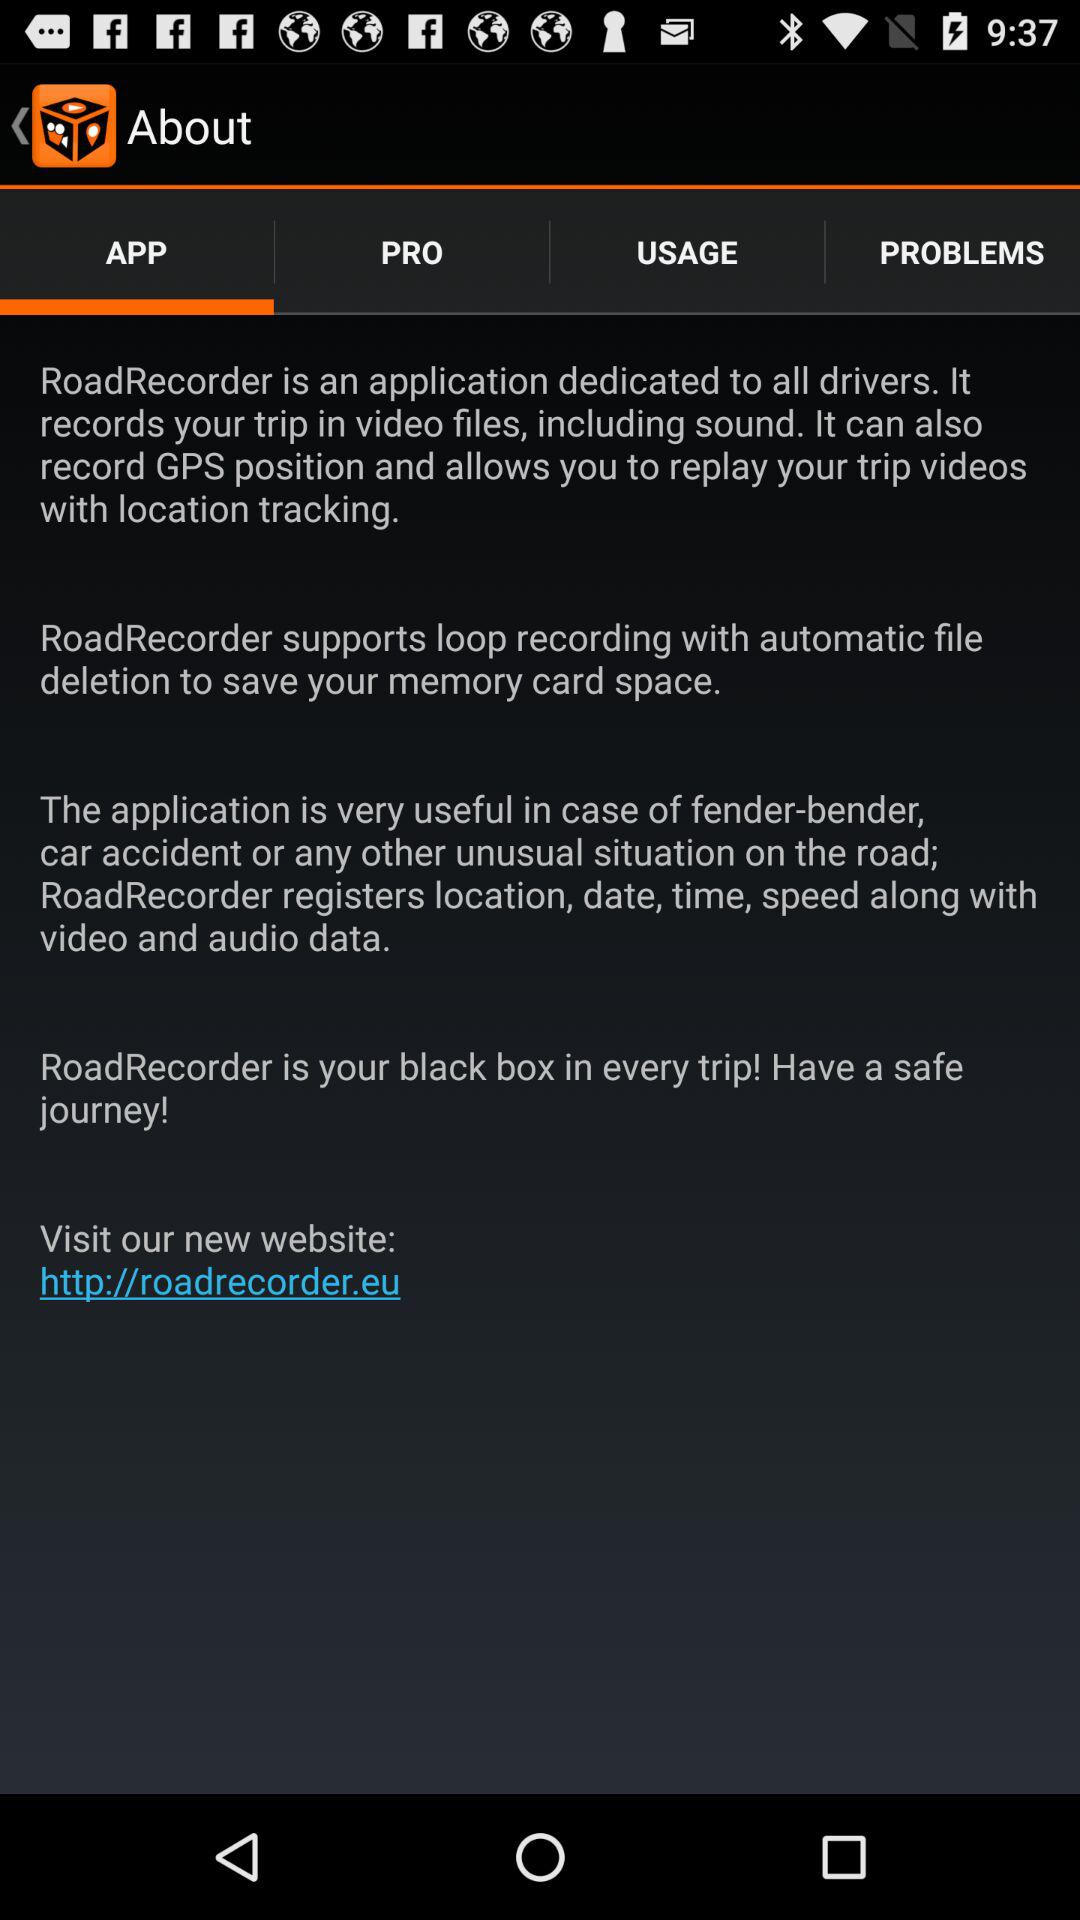What is "RoadRecorder"? It is an application dedicated to all drivers. It records your trip in video files, including sound. It can also record GPS position and allows you to replay your trip videos with location tracking. 